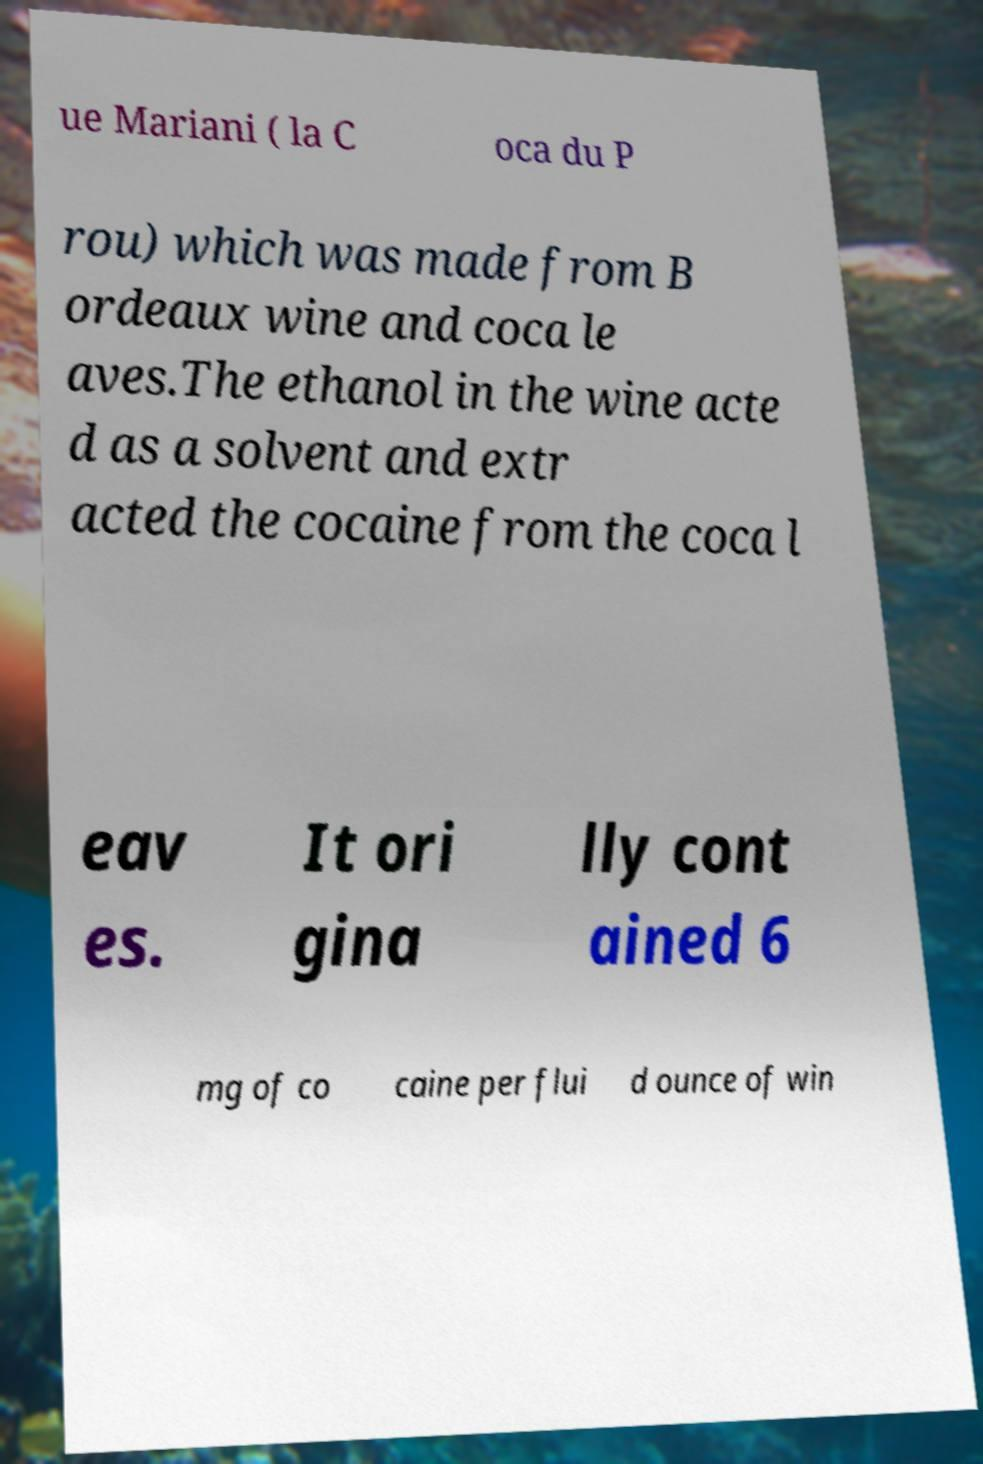Please read and relay the text visible in this image. What does it say? ue Mariani ( la C oca du P rou) which was made from B ordeaux wine and coca le aves.The ethanol in the wine acte d as a solvent and extr acted the cocaine from the coca l eav es. It ori gina lly cont ained 6 mg of co caine per flui d ounce of win 